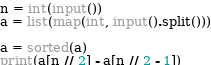<code> <loc_0><loc_0><loc_500><loc_500><_Python_>n = int(input())
a = list(map(int, input().split()))

a = sorted(a)
print(a[n // 2] - a[n // 2 - 1])</code> 